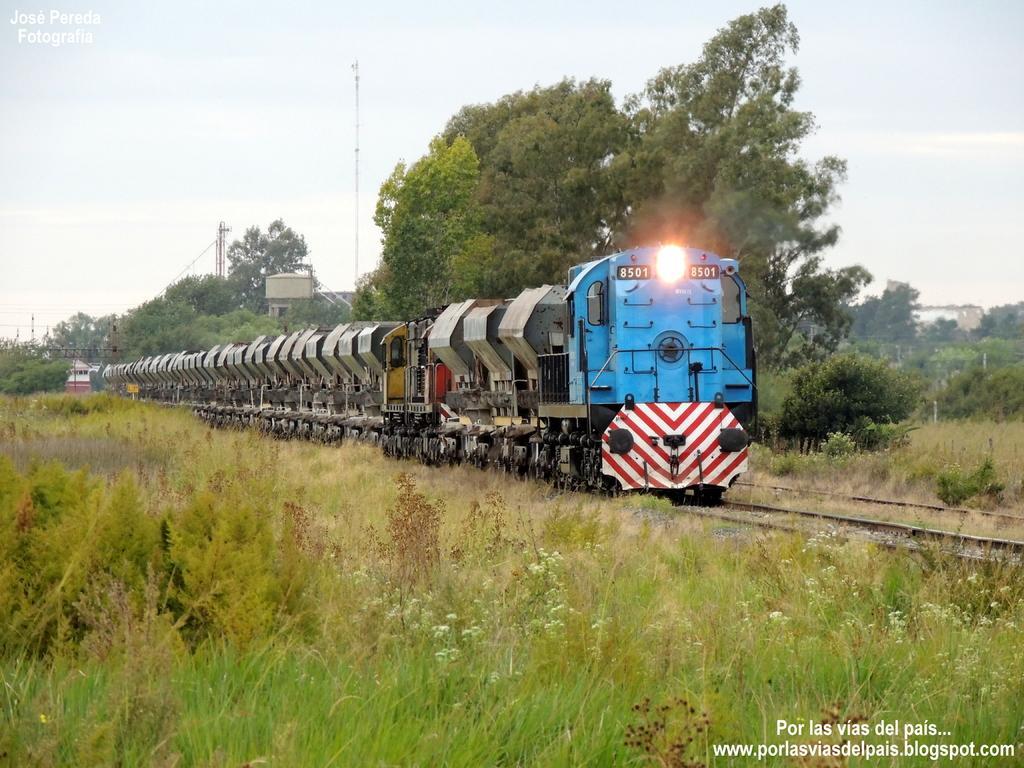Please provide a concise description of this image. The image is taken from some website, there is a train on the track and around the train there is a lot of greenery. 